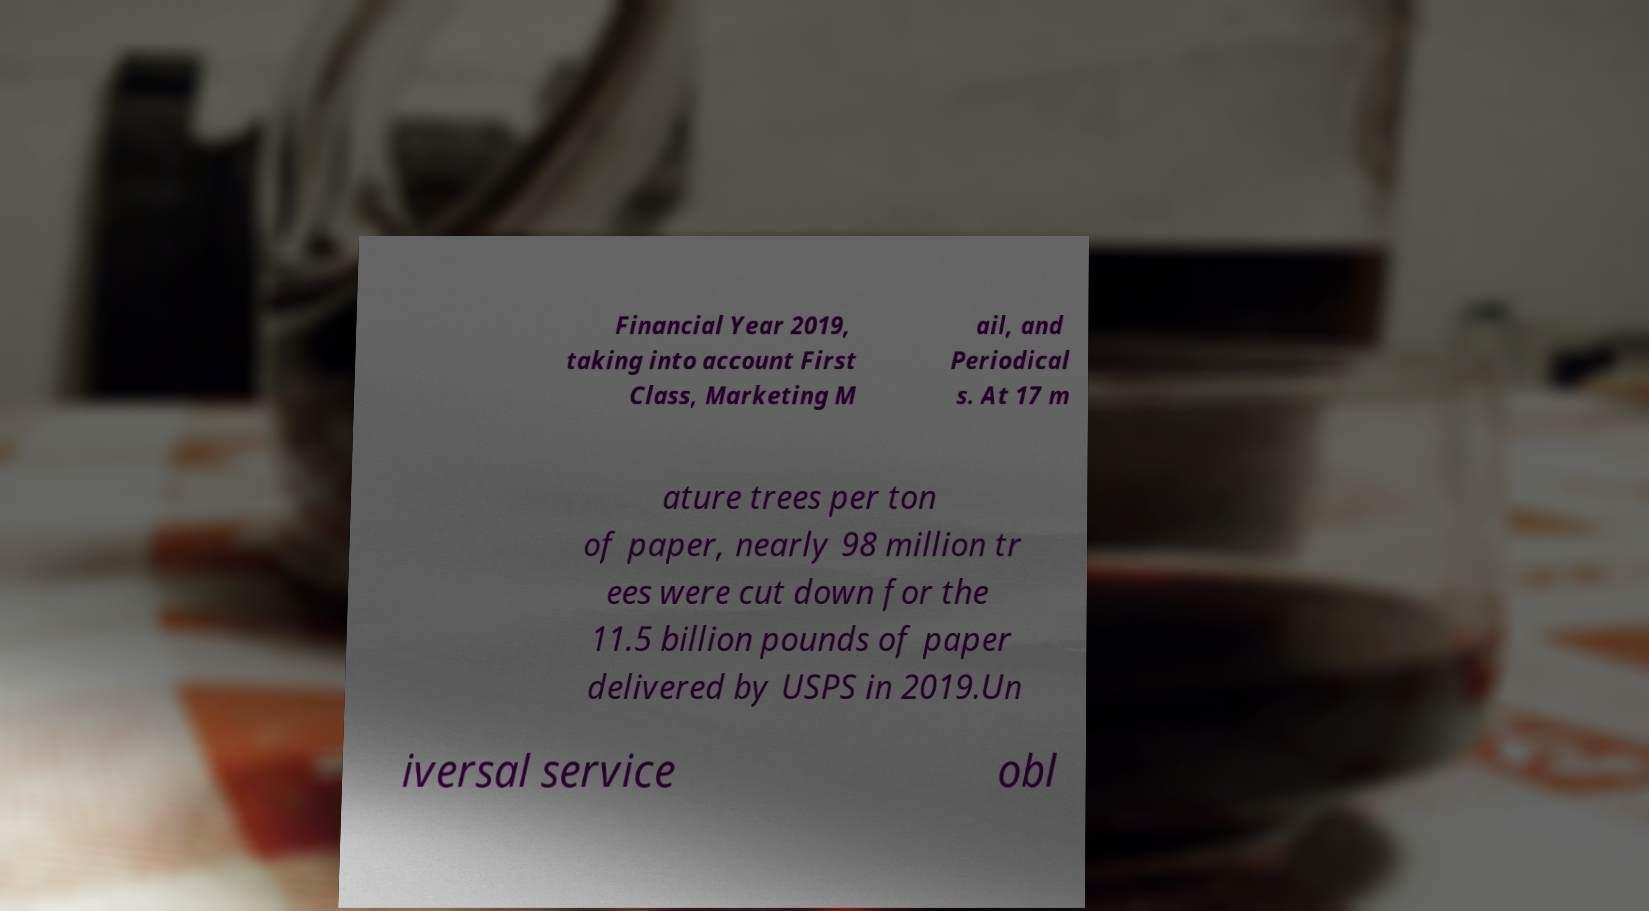Can you read and provide the text displayed in the image?This photo seems to have some interesting text. Can you extract and type it out for me? Financial Year 2019, taking into account First Class, Marketing M ail, and Periodical s. At 17 m ature trees per ton of paper, nearly 98 million tr ees were cut down for the 11.5 billion pounds of paper delivered by USPS in 2019.Un iversal service obl 